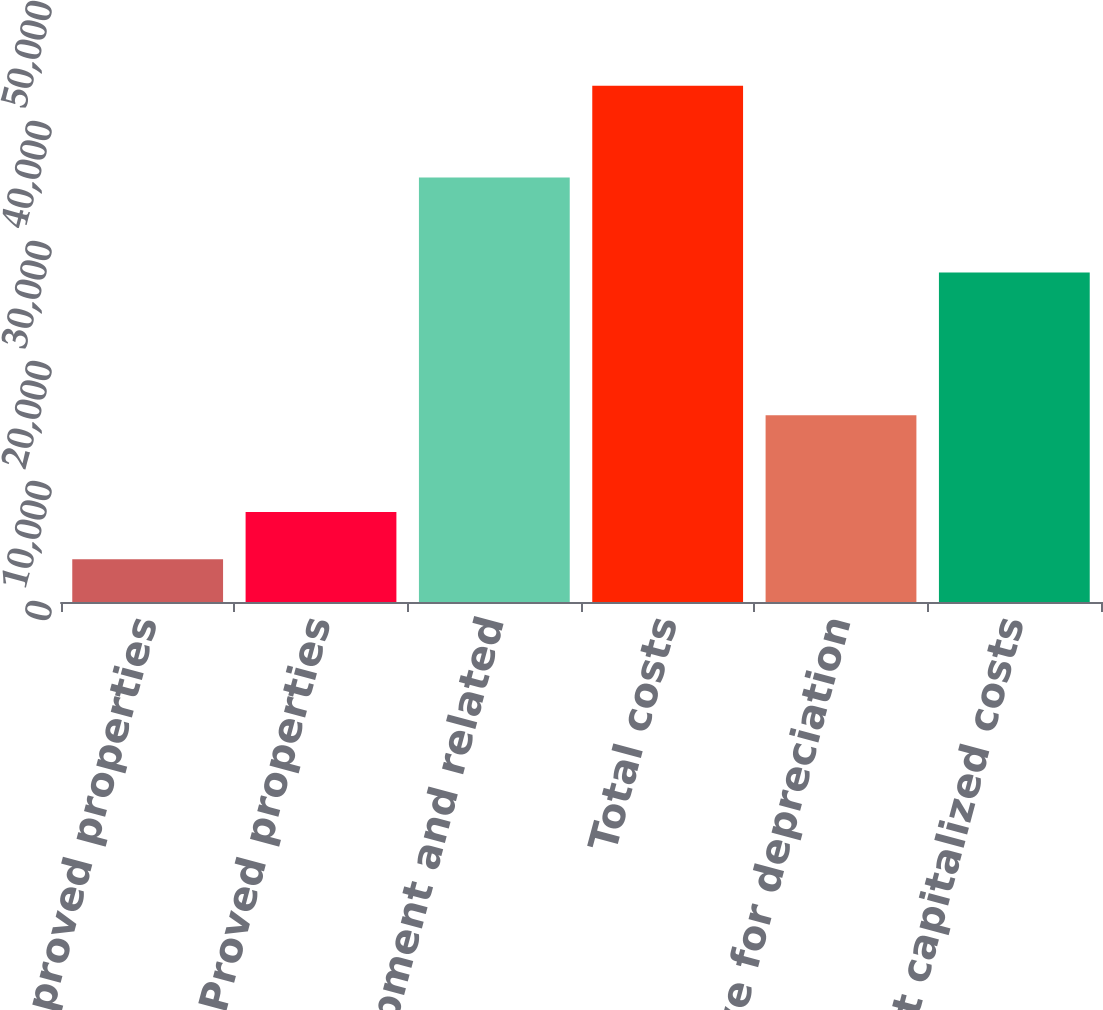Convert chart. <chart><loc_0><loc_0><loc_500><loc_500><bar_chart><fcel>Unproved properties<fcel>Proved properties<fcel>Wells equipment and related<fcel>Total costs<fcel>Less Reserve for depreciation<fcel>Net capitalized costs<nl><fcel>3558<fcel>7503.7<fcel>35385<fcel>43015<fcel>15558<fcel>27457<nl></chart> 